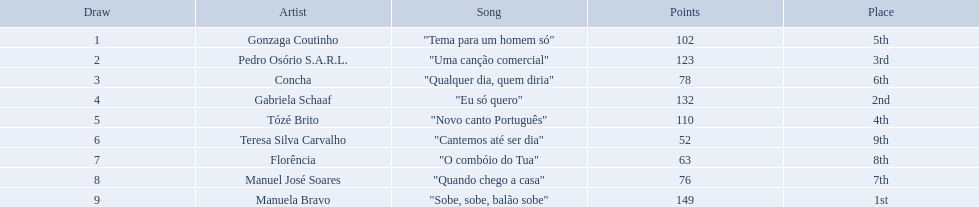Is there a song called eu so quero in the table? "Eu só quero". Who sang that song? Gabriela Schaaf. What song place second in the contest? "Eu só quero". Who sang eu so quero? Gabriela Schaaf. Parse the full table in json format. {'header': ['Draw', 'Artist', 'Song', 'Points', 'Place'], 'rows': [['1', 'Gonzaga Coutinho', '"Tema para um homem só"', '102', '5th'], ['2', 'Pedro Osório S.A.R.L.', '"Uma canção comercial"', '123', '3rd'], ['3', 'Concha', '"Qualquer dia, quem diria"', '78', '6th'], ['4', 'Gabriela Schaaf', '"Eu só quero"', '132', '2nd'], ['5', 'Tózé Brito', '"Novo canto Português"', '110', '4th'], ['6', 'Teresa Silva Carvalho', '"Cantemos até ser dia"', '52', '9th'], ['7', 'Florência', '"O combóio do Tua"', '63', '8th'], ['8', 'Manuel José Soares', '"Quando chego a casa"', '76', '7th'], ['9', 'Manuela Bravo', '"Sobe, sobe, balão sobe"', '149', '1st']]} What tune achieved the second position in the competition? "Eu só quero". Who vocalized eu so quero? Gabriela Schaaf. Which track secured the runner-up position in the competition? "Eu só quero". Who performed "eu so quero"? Gabriela Schaaf. 